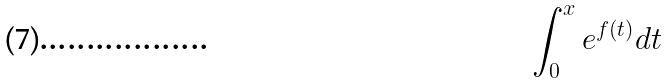Convert formula to latex. <formula><loc_0><loc_0><loc_500><loc_500>\int _ { 0 } ^ { x } e ^ { f ( t ) } d t</formula> 